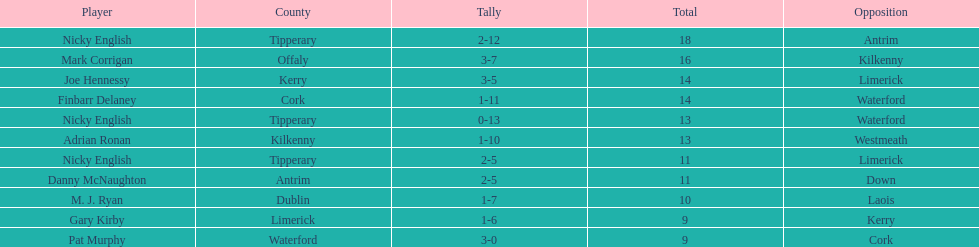Who ranked above mark corrigan? Nicky English. 